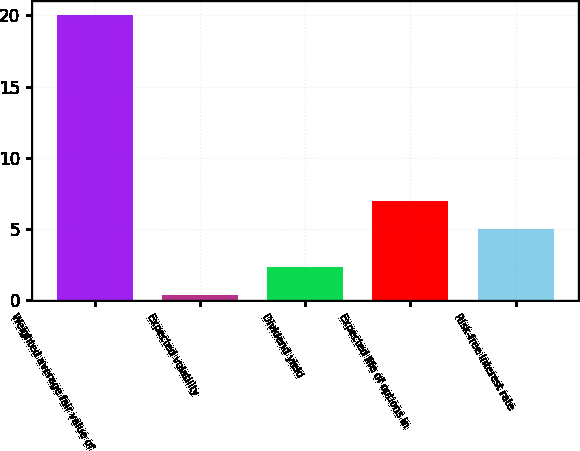<chart> <loc_0><loc_0><loc_500><loc_500><bar_chart><fcel>Weighted average fair value of<fcel>Expected volatility<fcel>Dividend yield<fcel>Expected life of options in<fcel>Risk-free interest rate<nl><fcel>20.01<fcel>0.35<fcel>2.32<fcel>6.97<fcel>5<nl></chart> 